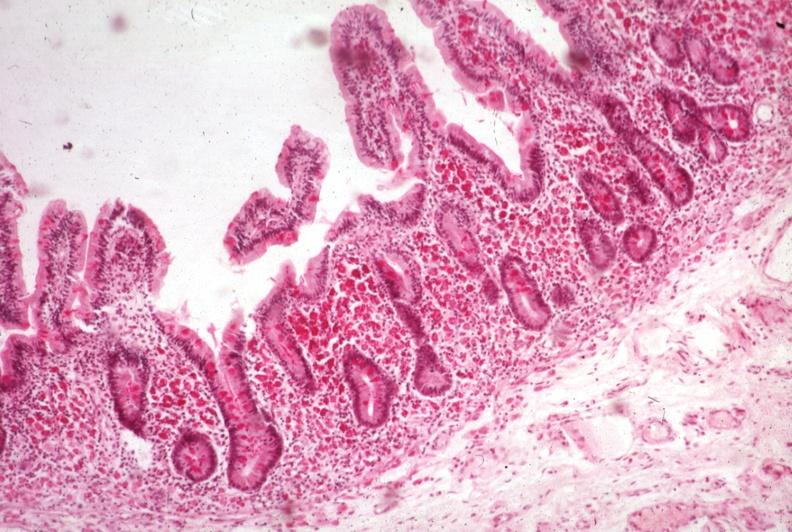what is present?
Answer the question using a single word or phrase. Whipples disease 